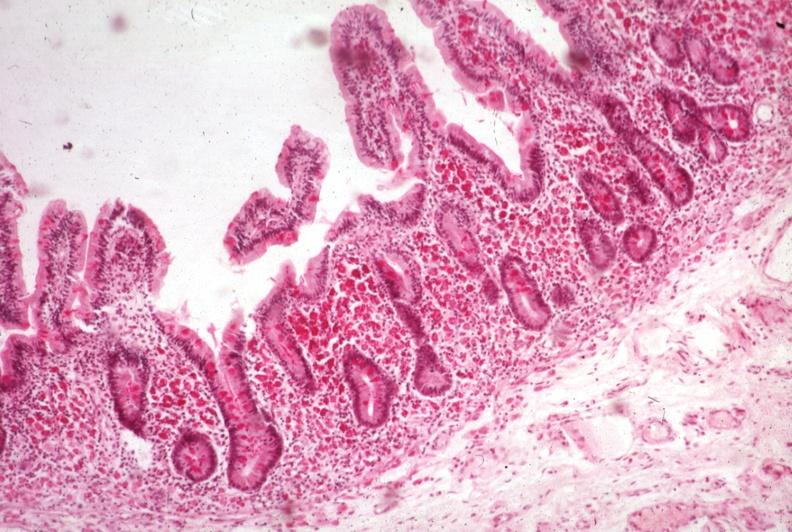what is present?
Answer the question using a single word or phrase. Whipples disease 